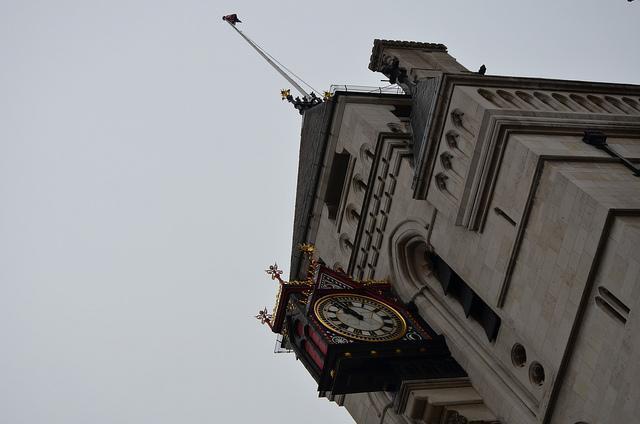How many people are in this picture?
Give a very brief answer. 0. 